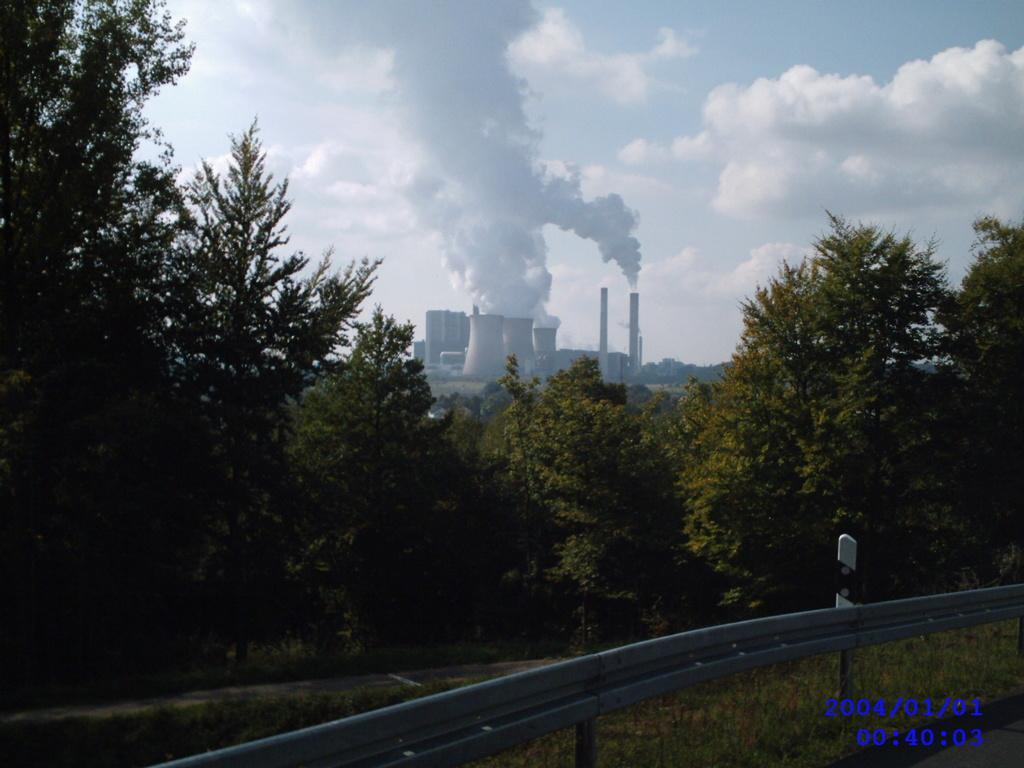What is coming out of the chimneys in the image? Smoke is coming out of the chimneys in the image. What type of vegetation can be seen in the image? Trees are visible in the image. What might be used to control traffic or pedestrians in the image? Barriers are present in the image. What type of ground cover is present in the image? Grass is present in the image. What is visible in the sky in the image? The sky is visible in the image, and clouds are present. What type of screw can be seen holding the chimney together in the image? There are no screws visible in the image; the focus is on the smoke coming from the chimneys. What type of farm animals can be seen grazing in the image? There are no farm animals present in the image; the focus is on the smoke, trees, barriers, grass, sky, and clouds. 